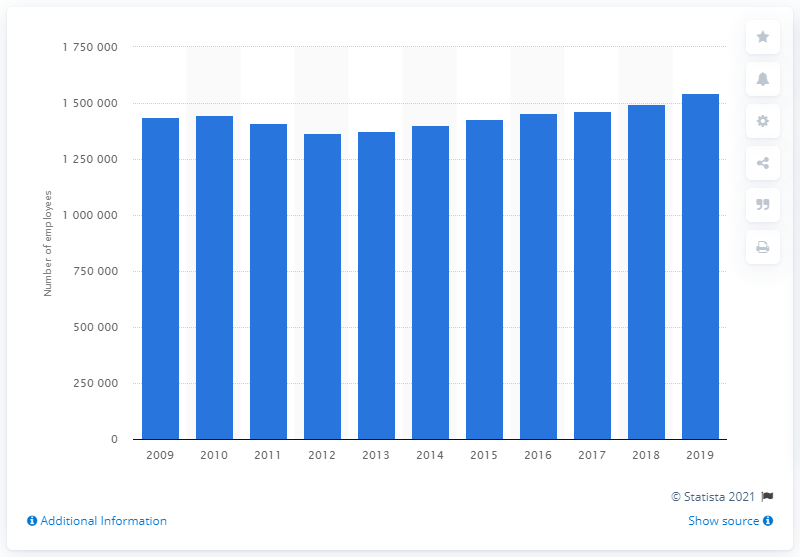Draw attention to some important aspects in this diagram. In 2019, there were approximately 1,543,387 hospital employees in the United Kingdom. 